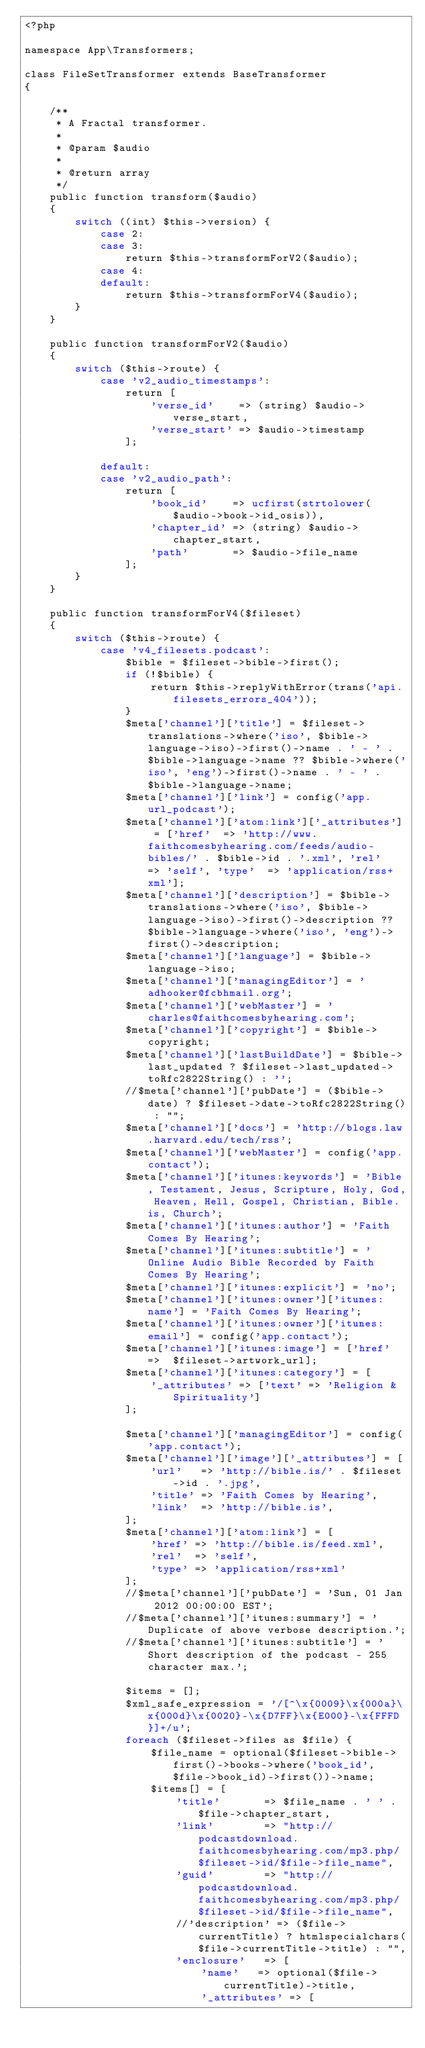Convert code to text. <code><loc_0><loc_0><loc_500><loc_500><_PHP_><?php

namespace App\Transformers;

class FileSetTransformer extends BaseTransformer
{

    /**
     * A Fractal transformer.
     *
     * @param $audio
     *
     * @return array
     */
    public function transform($audio)
    {
        switch ((int) $this->version) {
            case 2:
            case 3:
                return $this->transformForV2($audio);
            case 4:
            default:
                return $this->transformForV4($audio);
        }
    }

    public function transformForV2($audio)
    {
        switch ($this->route) {
            case 'v2_audio_timestamps':
                return [
                    'verse_id'    => (string) $audio->verse_start,
                    'verse_start' => $audio->timestamp
                ];

            default:
            case 'v2_audio_path':
                return [
                    'book_id'    => ucfirst(strtolower($audio->book->id_osis)),
                    'chapter_id' => (string) $audio->chapter_start,
                    'path'       => $audio->file_name
                ];
        }
    }

    public function transformForV4($fileset)
    {
        switch ($this->route) {
            case 'v4_filesets.podcast':
                $bible = $fileset->bible->first();
                if (!$bible) {
                    return $this->replyWithError(trans('api.filesets_errors_404'));
                }
                $meta['channel']['title'] = $fileset->translations->where('iso', $bible->language->iso)->first()->name . ' - ' . $bible->language->name ?? $bible->where('iso', 'eng')->first()->name . ' - ' . $bible->language->name;
                $meta['channel']['link'] = config('app.url_podcast');
                $meta['channel']['atom:link']['_attributes'] = ['href'  => 'http://www.faithcomesbyhearing.com/feeds/audio-bibles/' . $bible->id . '.xml', 'rel'   => 'self', 'type'  => 'application/rss+xml'];
                $meta['channel']['description'] = $bible->translations->where('iso', $bible->language->iso)->first()->description ?? $bible->language->where('iso', 'eng')->first()->description;
                $meta['channel']['language'] = $bible->language->iso;
                $meta['channel']['managingEditor'] = 'adhooker@fcbhmail.org';
                $meta['channel']['webMaster'] = 'charles@faithcomesbyhearing.com';
                $meta['channel']['copyright'] = $bible->copyright;
                $meta['channel']['lastBuildDate'] = $bible->last_updated ? $fileset->last_updated->toRfc2822String() : '';
                //$meta['channel']['pubDate'] = ($bible->date) ? $fileset->date->toRfc2822String() : "";
                $meta['channel']['docs'] = 'http://blogs.law.harvard.edu/tech/rss';
                $meta['channel']['webMaster'] = config('app.contact');
                $meta['channel']['itunes:keywords'] = 'Bible, Testament, Jesus, Scripture, Holy, God, Heaven, Hell, Gospel, Christian, Bible.is, Church';
                $meta['channel']['itunes:author'] = 'Faith Comes By Hearing';
                $meta['channel']['itunes:subtitle'] = 'Online Audio Bible Recorded by Faith Comes By Hearing';
                $meta['channel']['itunes:explicit'] = 'no';
                $meta['channel']['itunes:owner']['itunes:name'] = 'Faith Comes By Hearing';
                $meta['channel']['itunes:owner']['itunes:email'] = config('app.contact');
                $meta['channel']['itunes:image'] = ['href' =>  $fileset->artwork_url];
                $meta['channel']['itunes:category'] = [
                    '_attributes' => ['text' => 'Religion & Spirituality']
                ];

                $meta['channel']['managingEditor'] = config('app.contact');
                $meta['channel']['image']['_attributes'] = [
                    'url'   => 'http://bible.is/' . $fileset->id . '.jpg',
                    'title' => 'Faith Comes by Hearing',
                    'link'  => 'http://bible.is',
                ];
                $meta['channel']['atom:link'] = [
                    'href' => 'http://bible.is/feed.xml',
                    'rel'  => 'self',
                    'type' => 'application/rss+xml'
                ];
                //$meta['channel']['pubDate'] = 'Sun, 01 Jan 2012 00:00:00 EST';
                //$meta['channel']['itunes:summary'] = 'Duplicate of above verbose description.';
                //$meta['channel']['itunes:subtitle'] = 'Short description of the podcast - 255 character max.';

                $items = [];
                $xml_safe_expression = '/[^\x{0009}\x{000a}\x{000d}\x{0020}-\x{D7FF}\x{E000}-\x{FFFD}]+/u';
                foreach ($fileset->files as $file) {
                    $file_name = optional($fileset->bible->first()->books->where('book_id', $file->book_id)->first())->name;
                    $items[] = [
                        'title'       => $file_name . ' ' . $file->chapter_start,
                        'link'        => "http://podcastdownload.faithcomesbyhearing.com/mp3.php/$fileset->id/$file->file_name",
                        'guid'        => "http://podcastdownload.faithcomesbyhearing.com/mp3.php/$fileset->id/$file->file_name",
                        //'description' => ($file->currentTitle) ? htmlspecialchars($file->currentTitle->title) : "",
                        'enclosure'   => [
                            'name'   => optional($file->currentTitle)->title,
                            '_attributes' => [</code> 